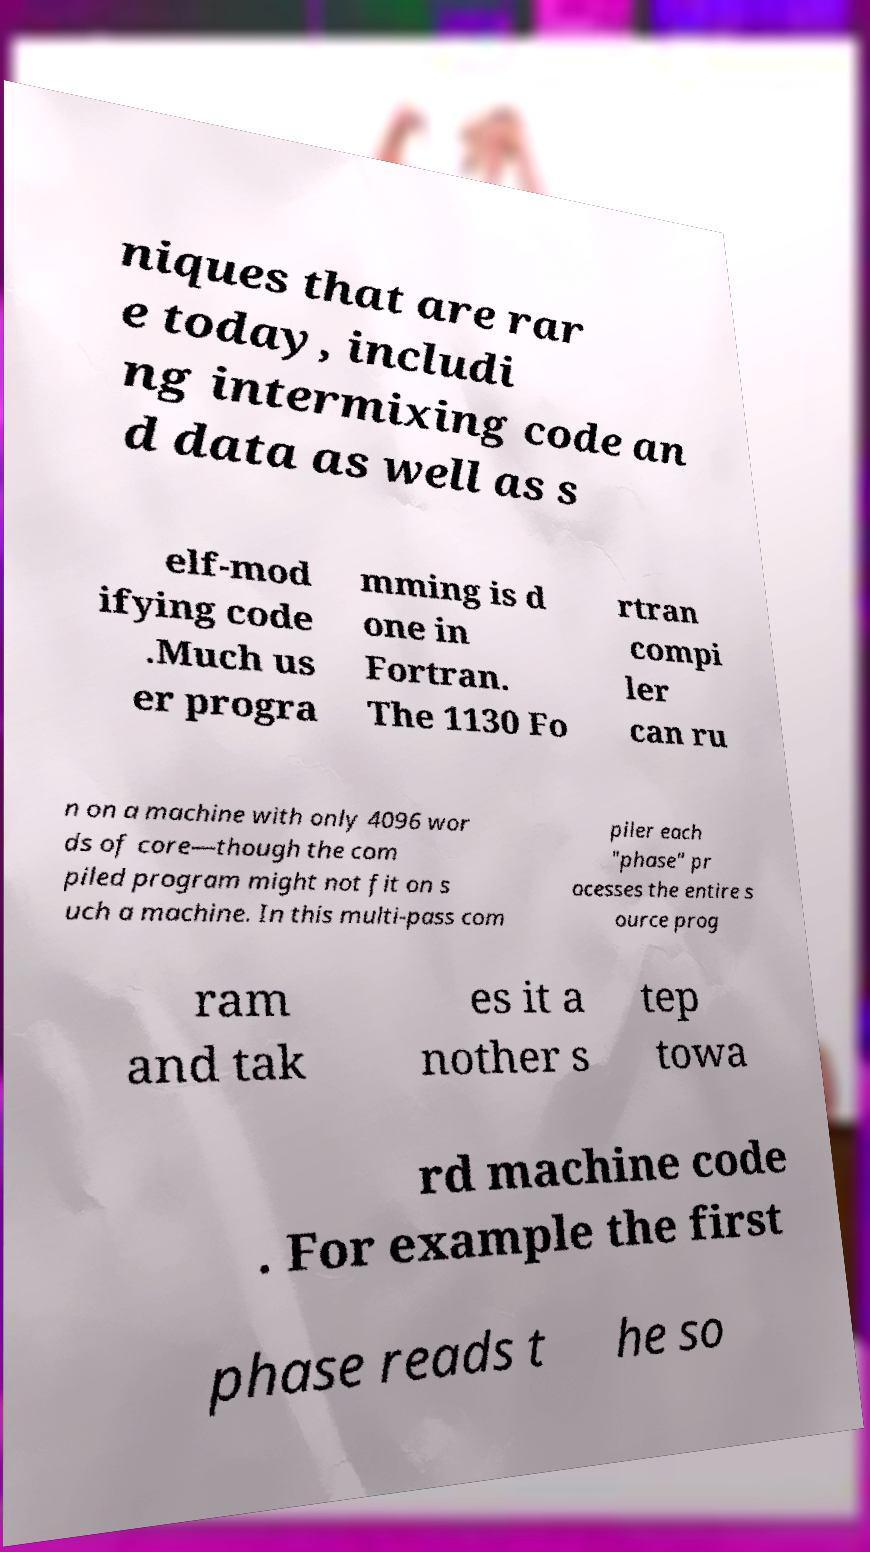Can you accurately transcribe the text from the provided image for me? niques that are rar e today, includi ng intermixing code an d data as well as s elf-mod ifying code .Much us er progra mming is d one in Fortran. The 1130 Fo rtran compi ler can ru n on a machine with only 4096 wor ds of core—though the com piled program might not fit on s uch a machine. In this multi-pass com piler each "phase" pr ocesses the entire s ource prog ram and tak es it a nother s tep towa rd machine code . For example the first phase reads t he so 